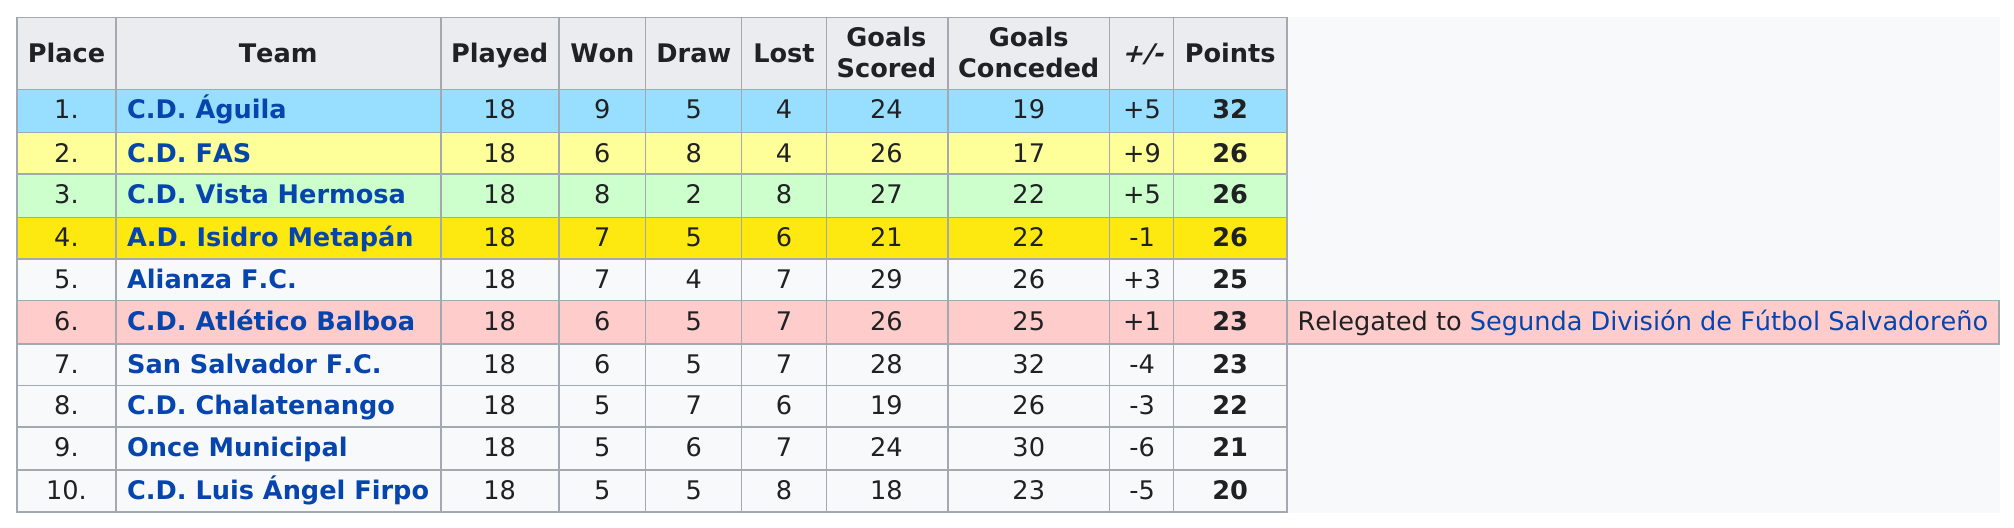Give some essential details in this illustration. The team that had the same amount of total points as CD Altietico Balboa was San Salvador F.C. Five teams scored at least 25 points or more. The team with the most wins is C.D. Águila. The team with the fewest losses was C.D. Águila and C.D. FAS. The team with the most points was C.D. Aguila. 